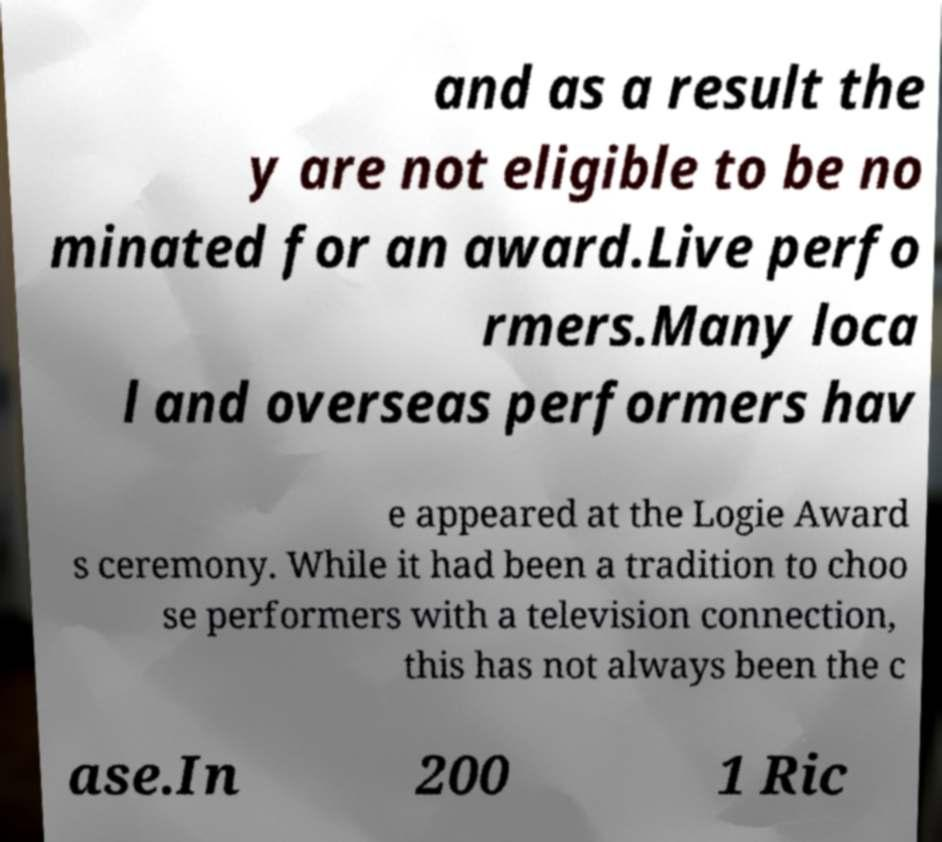What messages or text are displayed in this image? I need them in a readable, typed format. and as a result the y are not eligible to be no minated for an award.Live perfo rmers.Many loca l and overseas performers hav e appeared at the Logie Award s ceremony. While it had been a tradition to choo se performers with a television connection, this has not always been the c ase.In 200 1 Ric 